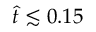<formula> <loc_0><loc_0><loc_500><loc_500>\hat { t } \lesssim 0 . 1 5</formula> 